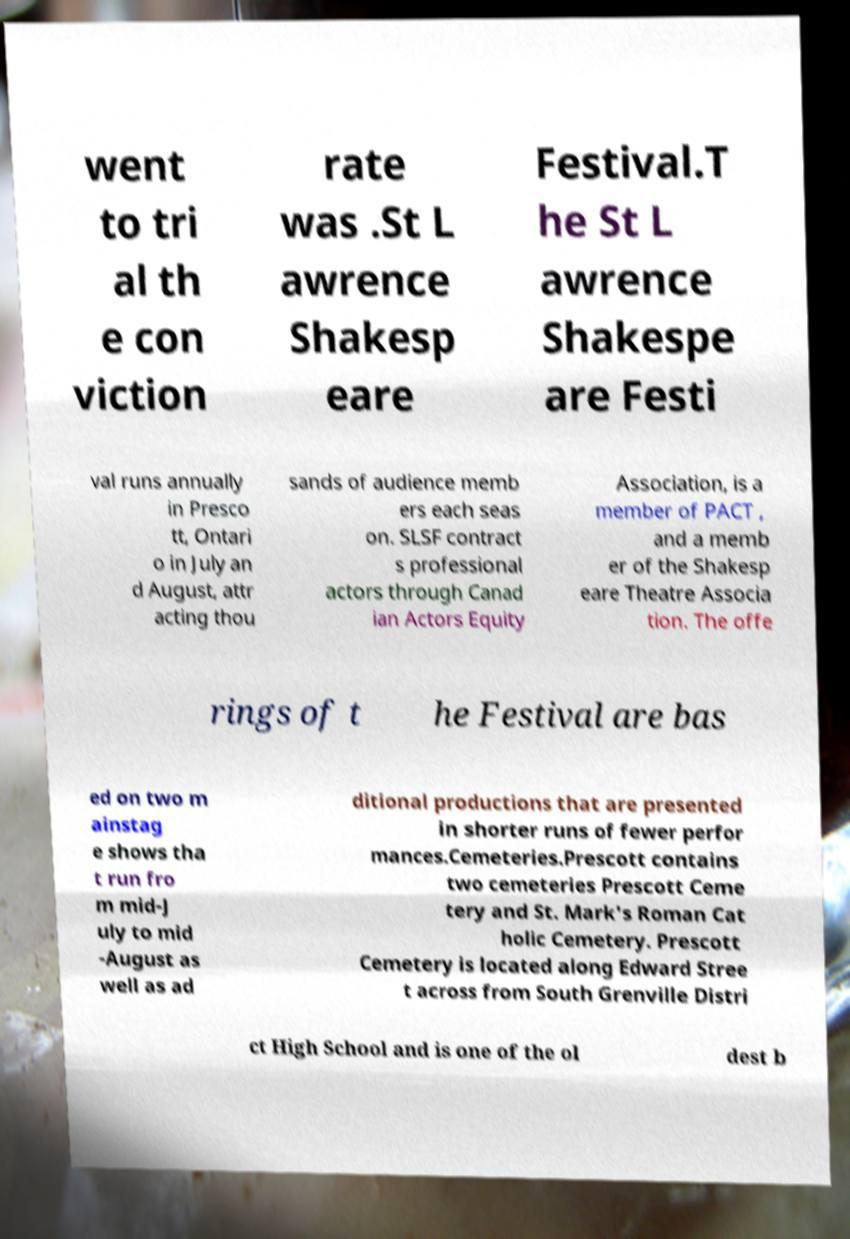Can you read and provide the text displayed in the image?This photo seems to have some interesting text. Can you extract and type it out for me? went to tri al th e con viction rate was .St L awrence Shakesp eare Festival.T he St L awrence Shakespe are Festi val runs annually in Presco tt, Ontari o in July an d August, attr acting thou sands of audience memb ers each seas on. SLSF contract s professional actors through Canad ian Actors Equity Association, is a member of PACT , and a memb er of the Shakesp eare Theatre Associa tion. The offe rings of t he Festival are bas ed on two m ainstag e shows tha t run fro m mid-J uly to mid -August as well as ad ditional productions that are presented in shorter runs of fewer perfor mances.Cemeteries.Prescott contains two cemeteries Prescott Ceme tery and St. Mark's Roman Cat holic Cemetery. Prescott Cemetery is located along Edward Stree t across from South Grenville Distri ct High School and is one of the ol dest b 